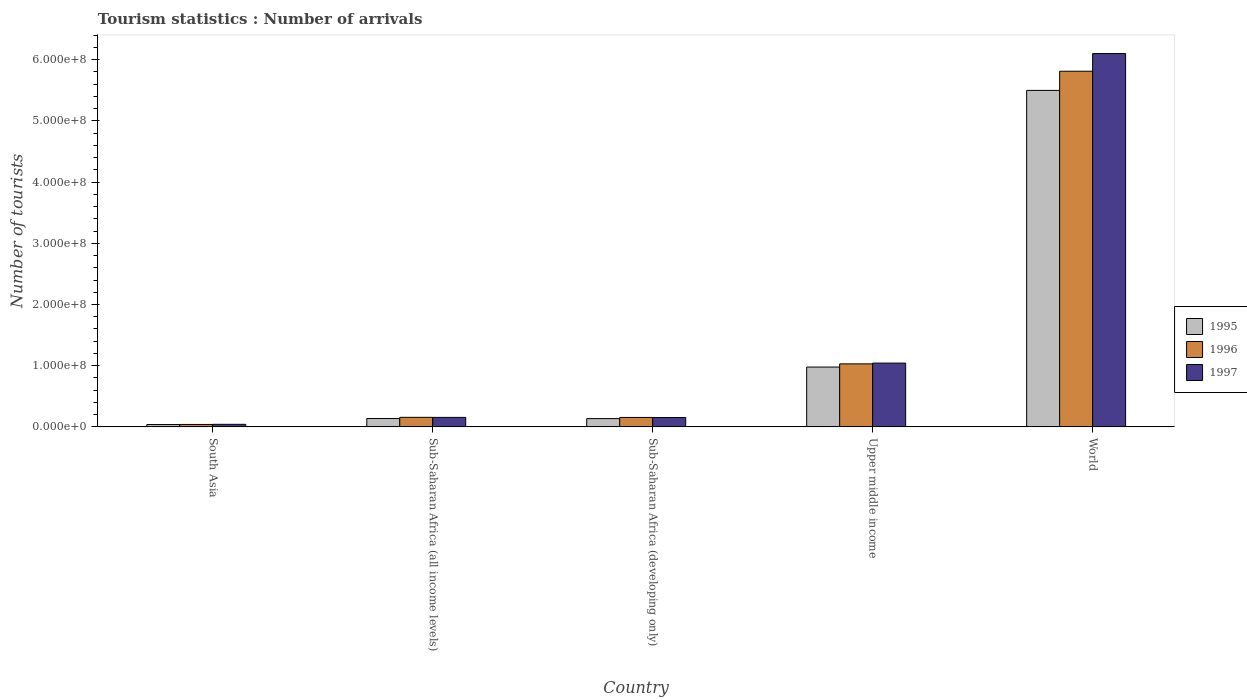How many different coloured bars are there?
Make the answer very short. 3. How many groups of bars are there?
Ensure brevity in your answer.  5. Are the number of bars per tick equal to the number of legend labels?
Your response must be concise. Yes. Are the number of bars on each tick of the X-axis equal?
Your answer should be compact. Yes. How many bars are there on the 4th tick from the right?
Your answer should be compact. 3. What is the label of the 2nd group of bars from the left?
Offer a very short reply. Sub-Saharan Africa (all income levels). What is the number of tourist arrivals in 1995 in Sub-Saharan Africa (all income levels)?
Your answer should be compact. 1.37e+07. Across all countries, what is the maximum number of tourist arrivals in 1997?
Provide a short and direct response. 6.10e+08. Across all countries, what is the minimum number of tourist arrivals in 1995?
Give a very brief answer. 3.82e+06. In which country was the number of tourist arrivals in 1996 maximum?
Offer a very short reply. World. What is the total number of tourist arrivals in 1996 in the graph?
Ensure brevity in your answer.  7.19e+08. What is the difference between the number of tourist arrivals in 1995 in Sub-Saharan Africa (all income levels) and that in World?
Provide a succinct answer. -5.36e+08. What is the difference between the number of tourist arrivals in 1997 in Sub-Saharan Africa (all income levels) and the number of tourist arrivals in 1995 in South Asia?
Your answer should be compact. 1.17e+07. What is the average number of tourist arrivals in 1996 per country?
Keep it short and to the point. 1.44e+08. What is the difference between the number of tourist arrivals of/in 1996 and number of tourist arrivals of/in 1997 in Sub-Saharan Africa (developing only)?
Give a very brief answer. 8.85e+04. What is the ratio of the number of tourist arrivals in 1996 in Sub-Saharan Africa (all income levels) to that in Sub-Saharan Africa (developing only)?
Make the answer very short. 1.01. What is the difference between the highest and the second highest number of tourist arrivals in 1997?
Offer a terse response. -8.87e+07. What is the difference between the highest and the lowest number of tourist arrivals in 1996?
Provide a short and direct response. 5.77e+08. In how many countries, is the number of tourist arrivals in 1995 greater than the average number of tourist arrivals in 1995 taken over all countries?
Provide a succinct answer. 1. Is the sum of the number of tourist arrivals in 1997 in South Asia and Sub-Saharan Africa (developing only) greater than the maximum number of tourist arrivals in 1995 across all countries?
Your response must be concise. No. What does the 3rd bar from the left in World represents?
Give a very brief answer. 1997. Is it the case that in every country, the sum of the number of tourist arrivals in 1997 and number of tourist arrivals in 1995 is greater than the number of tourist arrivals in 1996?
Offer a terse response. Yes. Are all the bars in the graph horizontal?
Make the answer very short. No. How many countries are there in the graph?
Your answer should be compact. 5. What is the difference between two consecutive major ticks on the Y-axis?
Make the answer very short. 1.00e+08. Does the graph contain grids?
Your answer should be compact. No. Where does the legend appear in the graph?
Offer a very short reply. Center right. How many legend labels are there?
Give a very brief answer. 3. What is the title of the graph?
Offer a terse response. Tourism statistics : Number of arrivals. Does "2008" appear as one of the legend labels in the graph?
Ensure brevity in your answer.  No. What is the label or title of the X-axis?
Provide a short and direct response. Country. What is the label or title of the Y-axis?
Offer a terse response. Number of tourists. What is the Number of tourists in 1995 in South Asia?
Make the answer very short. 3.82e+06. What is the Number of tourists of 1996 in South Asia?
Make the answer very short. 3.94e+06. What is the Number of tourists of 1997 in South Asia?
Provide a short and direct response. 4.17e+06. What is the Number of tourists of 1995 in Sub-Saharan Africa (all income levels)?
Provide a short and direct response. 1.37e+07. What is the Number of tourists in 1996 in Sub-Saharan Africa (all income levels)?
Offer a terse response. 1.56e+07. What is the Number of tourists of 1997 in Sub-Saharan Africa (all income levels)?
Give a very brief answer. 1.55e+07. What is the Number of tourists in 1995 in Sub-Saharan Africa (developing only)?
Provide a succinct answer. 1.35e+07. What is the Number of tourists of 1996 in Sub-Saharan Africa (developing only)?
Ensure brevity in your answer.  1.54e+07. What is the Number of tourists of 1997 in Sub-Saharan Africa (developing only)?
Provide a succinct answer. 1.53e+07. What is the Number of tourists in 1995 in Upper middle income?
Your answer should be compact. 9.78e+07. What is the Number of tourists of 1996 in Upper middle income?
Offer a terse response. 1.03e+08. What is the Number of tourists in 1997 in Upper middle income?
Make the answer very short. 1.04e+08. What is the Number of tourists of 1995 in World?
Give a very brief answer. 5.50e+08. What is the Number of tourists in 1996 in World?
Offer a terse response. 5.81e+08. What is the Number of tourists in 1997 in World?
Your answer should be compact. 6.10e+08. Across all countries, what is the maximum Number of tourists in 1995?
Offer a very short reply. 5.50e+08. Across all countries, what is the maximum Number of tourists of 1996?
Your answer should be very brief. 5.81e+08. Across all countries, what is the maximum Number of tourists in 1997?
Your answer should be very brief. 6.10e+08. Across all countries, what is the minimum Number of tourists of 1995?
Provide a succinct answer. 3.82e+06. Across all countries, what is the minimum Number of tourists of 1996?
Provide a succinct answer. 3.94e+06. Across all countries, what is the minimum Number of tourists in 1997?
Your answer should be very brief. 4.17e+06. What is the total Number of tourists of 1995 in the graph?
Make the answer very short. 6.79e+08. What is the total Number of tourists in 1996 in the graph?
Offer a very short reply. 7.19e+08. What is the total Number of tourists of 1997 in the graph?
Ensure brevity in your answer.  7.49e+08. What is the difference between the Number of tourists of 1995 in South Asia and that in Sub-Saharan Africa (all income levels)?
Offer a terse response. -9.84e+06. What is the difference between the Number of tourists in 1996 in South Asia and that in Sub-Saharan Africa (all income levels)?
Give a very brief answer. -1.16e+07. What is the difference between the Number of tourists in 1997 in South Asia and that in Sub-Saharan Africa (all income levels)?
Your response must be concise. -1.13e+07. What is the difference between the Number of tourists in 1995 in South Asia and that in Sub-Saharan Africa (developing only)?
Your answer should be very brief. -9.69e+06. What is the difference between the Number of tourists of 1996 in South Asia and that in Sub-Saharan Africa (developing only)?
Your response must be concise. -1.15e+07. What is the difference between the Number of tourists of 1997 in South Asia and that in Sub-Saharan Africa (developing only)?
Give a very brief answer. -1.12e+07. What is the difference between the Number of tourists in 1995 in South Asia and that in Upper middle income?
Provide a short and direct response. -9.39e+07. What is the difference between the Number of tourists in 1996 in South Asia and that in Upper middle income?
Ensure brevity in your answer.  -9.90e+07. What is the difference between the Number of tourists of 1997 in South Asia and that in Upper middle income?
Keep it short and to the point. -1.00e+08. What is the difference between the Number of tourists of 1995 in South Asia and that in World?
Provide a short and direct response. -5.46e+08. What is the difference between the Number of tourists in 1996 in South Asia and that in World?
Provide a succinct answer. -5.77e+08. What is the difference between the Number of tourists in 1997 in South Asia and that in World?
Keep it short and to the point. -6.06e+08. What is the difference between the Number of tourists in 1995 in Sub-Saharan Africa (all income levels) and that in Sub-Saharan Africa (developing only)?
Your answer should be compact. 1.47e+05. What is the difference between the Number of tourists of 1996 in Sub-Saharan Africa (all income levels) and that in Sub-Saharan Africa (developing only)?
Give a very brief answer. 1.60e+05. What is the difference between the Number of tourists in 1997 in Sub-Saharan Africa (all income levels) and that in Sub-Saharan Africa (developing only)?
Your answer should be compact. 1.59e+05. What is the difference between the Number of tourists of 1995 in Sub-Saharan Africa (all income levels) and that in Upper middle income?
Give a very brief answer. -8.41e+07. What is the difference between the Number of tourists in 1996 in Sub-Saharan Africa (all income levels) and that in Upper middle income?
Provide a succinct answer. -8.74e+07. What is the difference between the Number of tourists in 1997 in Sub-Saharan Africa (all income levels) and that in Upper middle income?
Your response must be concise. -8.87e+07. What is the difference between the Number of tourists in 1995 in Sub-Saharan Africa (all income levels) and that in World?
Offer a terse response. -5.36e+08. What is the difference between the Number of tourists of 1996 in Sub-Saharan Africa (all income levels) and that in World?
Offer a very short reply. -5.66e+08. What is the difference between the Number of tourists of 1997 in Sub-Saharan Africa (all income levels) and that in World?
Make the answer very short. -5.95e+08. What is the difference between the Number of tourists in 1995 in Sub-Saharan Africa (developing only) and that in Upper middle income?
Your response must be concise. -8.42e+07. What is the difference between the Number of tourists of 1996 in Sub-Saharan Africa (developing only) and that in Upper middle income?
Offer a very short reply. -8.75e+07. What is the difference between the Number of tourists in 1997 in Sub-Saharan Africa (developing only) and that in Upper middle income?
Keep it short and to the point. -8.89e+07. What is the difference between the Number of tourists of 1995 in Sub-Saharan Africa (developing only) and that in World?
Offer a terse response. -5.36e+08. What is the difference between the Number of tourists in 1996 in Sub-Saharan Africa (developing only) and that in World?
Your answer should be very brief. -5.66e+08. What is the difference between the Number of tourists in 1997 in Sub-Saharan Africa (developing only) and that in World?
Ensure brevity in your answer.  -5.95e+08. What is the difference between the Number of tourists of 1995 in Upper middle income and that in World?
Your answer should be very brief. -4.52e+08. What is the difference between the Number of tourists of 1996 in Upper middle income and that in World?
Offer a very short reply. -4.78e+08. What is the difference between the Number of tourists in 1997 in Upper middle income and that in World?
Give a very brief answer. -5.06e+08. What is the difference between the Number of tourists in 1995 in South Asia and the Number of tourists in 1996 in Sub-Saharan Africa (all income levels)?
Keep it short and to the point. -1.18e+07. What is the difference between the Number of tourists in 1995 in South Asia and the Number of tourists in 1997 in Sub-Saharan Africa (all income levels)?
Provide a short and direct response. -1.17e+07. What is the difference between the Number of tourists in 1996 in South Asia and the Number of tourists in 1997 in Sub-Saharan Africa (all income levels)?
Offer a very short reply. -1.15e+07. What is the difference between the Number of tourists of 1995 in South Asia and the Number of tourists of 1996 in Sub-Saharan Africa (developing only)?
Your answer should be compact. -1.16e+07. What is the difference between the Number of tourists in 1995 in South Asia and the Number of tourists in 1997 in Sub-Saharan Africa (developing only)?
Your response must be concise. -1.15e+07. What is the difference between the Number of tourists of 1996 in South Asia and the Number of tourists of 1997 in Sub-Saharan Africa (developing only)?
Make the answer very short. -1.14e+07. What is the difference between the Number of tourists of 1995 in South Asia and the Number of tourists of 1996 in Upper middle income?
Keep it short and to the point. -9.91e+07. What is the difference between the Number of tourists in 1995 in South Asia and the Number of tourists in 1997 in Upper middle income?
Your answer should be very brief. -1.00e+08. What is the difference between the Number of tourists in 1996 in South Asia and the Number of tourists in 1997 in Upper middle income?
Give a very brief answer. -1.00e+08. What is the difference between the Number of tourists in 1995 in South Asia and the Number of tourists in 1996 in World?
Offer a very short reply. -5.77e+08. What is the difference between the Number of tourists in 1995 in South Asia and the Number of tourists in 1997 in World?
Your answer should be compact. -6.06e+08. What is the difference between the Number of tourists in 1996 in South Asia and the Number of tourists in 1997 in World?
Provide a succinct answer. -6.06e+08. What is the difference between the Number of tourists in 1995 in Sub-Saharan Africa (all income levels) and the Number of tourists in 1996 in Sub-Saharan Africa (developing only)?
Give a very brief answer. -1.76e+06. What is the difference between the Number of tourists of 1995 in Sub-Saharan Africa (all income levels) and the Number of tourists of 1997 in Sub-Saharan Africa (developing only)?
Your answer should be compact. -1.67e+06. What is the difference between the Number of tourists in 1996 in Sub-Saharan Africa (all income levels) and the Number of tourists in 1997 in Sub-Saharan Africa (developing only)?
Make the answer very short. 2.49e+05. What is the difference between the Number of tourists of 1995 in Sub-Saharan Africa (all income levels) and the Number of tourists of 1996 in Upper middle income?
Provide a succinct answer. -8.93e+07. What is the difference between the Number of tourists in 1995 in Sub-Saharan Africa (all income levels) and the Number of tourists in 1997 in Upper middle income?
Give a very brief answer. -9.06e+07. What is the difference between the Number of tourists of 1996 in Sub-Saharan Africa (all income levels) and the Number of tourists of 1997 in Upper middle income?
Provide a short and direct response. -8.86e+07. What is the difference between the Number of tourists of 1995 in Sub-Saharan Africa (all income levels) and the Number of tourists of 1996 in World?
Make the answer very short. -5.68e+08. What is the difference between the Number of tourists of 1995 in Sub-Saharan Africa (all income levels) and the Number of tourists of 1997 in World?
Provide a succinct answer. -5.96e+08. What is the difference between the Number of tourists in 1996 in Sub-Saharan Africa (all income levels) and the Number of tourists in 1997 in World?
Your response must be concise. -5.95e+08. What is the difference between the Number of tourists in 1995 in Sub-Saharan Africa (developing only) and the Number of tourists in 1996 in Upper middle income?
Your answer should be compact. -8.94e+07. What is the difference between the Number of tourists in 1995 in Sub-Saharan Africa (developing only) and the Number of tourists in 1997 in Upper middle income?
Make the answer very short. -9.07e+07. What is the difference between the Number of tourists of 1996 in Sub-Saharan Africa (developing only) and the Number of tourists of 1997 in Upper middle income?
Give a very brief answer. -8.88e+07. What is the difference between the Number of tourists of 1995 in Sub-Saharan Africa (developing only) and the Number of tourists of 1996 in World?
Give a very brief answer. -5.68e+08. What is the difference between the Number of tourists of 1995 in Sub-Saharan Africa (developing only) and the Number of tourists of 1997 in World?
Your answer should be very brief. -5.97e+08. What is the difference between the Number of tourists of 1996 in Sub-Saharan Africa (developing only) and the Number of tourists of 1997 in World?
Your answer should be very brief. -5.95e+08. What is the difference between the Number of tourists of 1995 in Upper middle income and the Number of tourists of 1996 in World?
Your response must be concise. -4.83e+08. What is the difference between the Number of tourists of 1995 in Upper middle income and the Number of tourists of 1997 in World?
Give a very brief answer. -5.12e+08. What is the difference between the Number of tourists of 1996 in Upper middle income and the Number of tourists of 1997 in World?
Your answer should be very brief. -5.07e+08. What is the average Number of tourists of 1995 per country?
Keep it short and to the point. 1.36e+08. What is the average Number of tourists of 1996 per country?
Your answer should be very brief. 1.44e+08. What is the average Number of tourists of 1997 per country?
Offer a very short reply. 1.50e+08. What is the difference between the Number of tourists in 1995 and Number of tourists in 1996 in South Asia?
Keep it short and to the point. -1.21e+05. What is the difference between the Number of tourists in 1995 and Number of tourists in 1997 in South Asia?
Provide a succinct answer. -3.53e+05. What is the difference between the Number of tourists in 1996 and Number of tourists in 1997 in South Asia?
Your response must be concise. -2.32e+05. What is the difference between the Number of tourists of 1995 and Number of tourists of 1996 in Sub-Saharan Africa (all income levels)?
Provide a short and direct response. -1.92e+06. What is the difference between the Number of tourists of 1995 and Number of tourists of 1997 in Sub-Saharan Africa (all income levels)?
Your answer should be very brief. -1.83e+06. What is the difference between the Number of tourists of 1996 and Number of tourists of 1997 in Sub-Saharan Africa (all income levels)?
Keep it short and to the point. 8.97e+04. What is the difference between the Number of tourists in 1995 and Number of tourists in 1996 in Sub-Saharan Africa (developing only)?
Make the answer very short. -1.91e+06. What is the difference between the Number of tourists of 1995 and Number of tourists of 1997 in Sub-Saharan Africa (developing only)?
Your answer should be very brief. -1.82e+06. What is the difference between the Number of tourists in 1996 and Number of tourists in 1997 in Sub-Saharan Africa (developing only)?
Make the answer very short. 8.85e+04. What is the difference between the Number of tourists in 1995 and Number of tourists in 1996 in Upper middle income?
Your answer should be compact. -5.20e+06. What is the difference between the Number of tourists of 1995 and Number of tourists of 1997 in Upper middle income?
Provide a short and direct response. -6.47e+06. What is the difference between the Number of tourists in 1996 and Number of tourists in 1997 in Upper middle income?
Offer a very short reply. -1.27e+06. What is the difference between the Number of tourists in 1995 and Number of tourists in 1996 in World?
Your answer should be very brief. -3.13e+07. What is the difference between the Number of tourists in 1995 and Number of tourists in 1997 in World?
Provide a succinct answer. -6.02e+07. What is the difference between the Number of tourists of 1996 and Number of tourists of 1997 in World?
Provide a succinct answer. -2.89e+07. What is the ratio of the Number of tourists in 1995 in South Asia to that in Sub-Saharan Africa (all income levels)?
Your answer should be very brief. 0.28. What is the ratio of the Number of tourists in 1996 in South Asia to that in Sub-Saharan Africa (all income levels)?
Your answer should be very brief. 0.25. What is the ratio of the Number of tourists in 1997 in South Asia to that in Sub-Saharan Africa (all income levels)?
Provide a short and direct response. 0.27. What is the ratio of the Number of tourists in 1995 in South Asia to that in Sub-Saharan Africa (developing only)?
Make the answer very short. 0.28. What is the ratio of the Number of tourists of 1996 in South Asia to that in Sub-Saharan Africa (developing only)?
Your answer should be compact. 0.26. What is the ratio of the Number of tourists of 1997 in South Asia to that in Sub-Saharan Africa (developing only)?
Your response must be concise. 0.27. What is the ratio of the Number of tourists in 1995 in South Asia to that in Upper middle income?
Your answer should be very brief. 0.04. What is the ratio of the Number of tourists in 1996 in South Asia to that in Upper middle income?
Keep it short and to the point. 0.04. What is the ratio of the Number of tourists of 1997 in South Asia to that in Upper middle income?
Your response must be concise. 0.04. What is the ratio of the Number of tourists in 1995 in South Asia to that in World?
Keep it short and to the point. 0.01. What is the ratio of the Number of tourists in 1996 in South Asia to that in World?
Your response must be concise. 0.01. What is the ratio of the Number of tourists of 1997 in South Asia to that in World?
Make the answer very short. 0.01. What is the ratio of the Number of tourists in 1995 in Sub-Saharan Africa (all income levels) to that in Sub-Saharan Africa (developing only)?
Ensure brevity in your answer.  1.01. What is the ratio of the Number of tourists in 1996 in Sub-Saharan Africa (all income levels) to that in Sub-Saharan Africa (developing only)?
Give a very brief answer. 1.01. What is the ratio of the Number of tourists of 1997 in Sub-Saharan Africa (all income levels) to that in Sub-Saharan Africa (developing only)?
Provide a short and direct response. 1.01. What is the ratio of the Number of tourists in 1995 in Sub-Saharan Africa (all income levels) to that in Upper middle income?
Your response must be concise. 0.14. What is the ratio of the Number of tourists of 1996 in Sub-Saharan Africa (all income levels) to that in Upper middle income?
Keep it short and to the point. 0.15. What is the ratio of the Number of tourists in 1997 in Sub-Saharan Africa (all income levels) to that in Upper middle income?
Provide a succinct answer. 0.15. What is the ratio of the Number of tourists of 1995 in Sub-Saharan Africa (all income levels) to that in World?
Make the answer very short. 0.02. What is the ratio of the Number of tourists of 1996 in Sub-Saharan Africa (all income levels) to that in World?
Provide a succinct answer. 0.03. What is the ratio of the Number of tourists in 1997 in Sub-Saharan Africa (all income levels) to that in World?
Provide a short and direct response. 0.03. What is the ratio of the Number of tourists in 1995 in Sub-Saharan Africa (developing only) to that in Upper middle income?
Offer a very short reply. 0.14. What is the ratio of the Number of tourists in 1996 in Sub-Saharan Africa (developing only) to that in Upper middle income?
Ensure brevity in your answer.  0.15. What is the ratio of the Number of tourists in 1997 in Sub-Saharan Africa (developing only) to that in Upper middle income?
Ensure brevity in your answer.  0.15. What is the ratio of the Number of tourists in 1995 in Sub-Saharan Africa (developing only) to that in World?
Offer a terse response. 0.02. What is the ratio of the Number of tourists in 1996 in Sub-Saharan Africa (developing only) to that in World?
Your answer should be compact. 0.03. What is the ratio of the Number of tourists of 1997 in Sub-Saharan Africa (developing only) to that in World?
Offer a very short reply. 0.03. What is the ratio of the Number of tourists of 1995 in Upper middle income to that in World?
Give a very brief answer. 0.18. What is the ratio of the Number of tourists of 1996 in Upper middle income to that in World?
Your answer should be very brief. 0.18. What is the ratio of the Number of tourists of 1997 in Upper middle income to that in World?
Offer a very short reply. 0.17. What is the difference between the highest and the second highest Number of tourists of 1995?
Offer a terse response. 4.52e+08. What is the difference between the highest and the second highest Number of tourists in 1996?
Offer a terse response. 4.78e+08. What is the difference between the highest and the second highest Number of tourists in 1997?
Provide a succinct answer. 5.06e+08. What is the difference between the highest and the lowest Number of tourists of 1995?
Offer a very short reply. 5.46e+08. What is the difference between the highest and the lowest Number of tourists of 1996?
Provide a short and direct response. 5.77e+08. What is the difference between the highest and the lowest Number of tourists of 1997?
Give a very brief answer. 6.06e+08. 